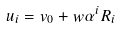<formula> <loc_0><loc_0><loc_500><loc_500>u _ { i } = v _ { 0 } + w \alpha ^ { i } R _ { i }</formula> 